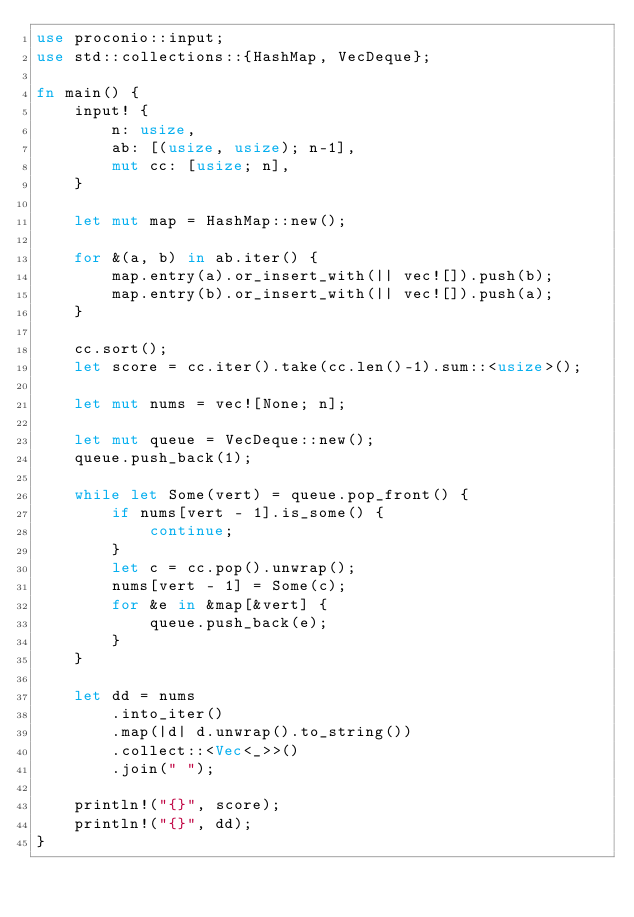<code> <loc_0><loc_0><loc_500><loc_500><_Rust_>use proconio::input;
use std::collections::{HashMap, VecDeque};

fn main() {
    input! {
        n: usize,
        ab: [(usize, usize); n-1],
        mut cc: [usize; n],
    }

    let mut map = HashMap::new();

    for &(a, b) in ab.iter() {
        map.entry(a).or_insert_with(|| vec![]).push(b);
        map.entry(b).or_insert_with(|| vec![]).push(a);
    }

    cc.sort();
    let score = cc.iter().take(cc.len()-1).sum::<usize>();

    let mut nums = vec![None; n];

    let mut queue = VecDeque::new();
    queue.push_back(1);

    while let Some(vert) = queue.pop_front() {
        if nums[vert - 1].is_some() {
            continue;
        }
        let c = cc.pop().unwrap();
        nums[vert - 1] = Some(c);
        for &e in &map[&vert] {
            queue.push_back(e);
        }
    }

    let dd = nums
        .into_iter()
        .map(|d| d.unwrap().to_string())
        .collect::<Vec<_>>()
        .join(" ");

    println!("{}", score);
    println!("{}", dd);
}
</code> 